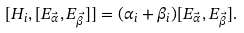Convert formula to latex. <formula><loc_0><loc_0><loc_500><loc_500>[ H _ { i } , [ E _ { \vec { \alpha } } , E _ { \vec { \beta } } ] ] = ( \alpha _ { i } + \beta _ { i } ) [ E _ { \vec { \alpha } } , E _ { \vec { \beta } } ] .</formula> 